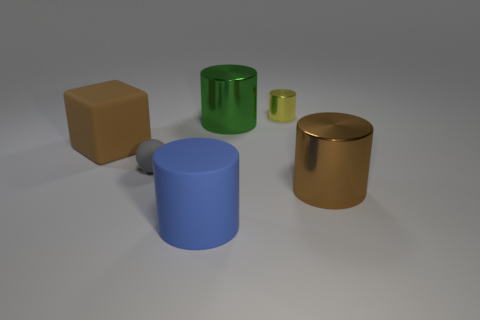Subtract all small yellow cylinders. How many cylinders are left? 3 Add 4 rubber cubes. How many objects exist? 10 Subtract all balls. How many objects are left? 5 Subtract all yellow cylinders. How many cylinders are left? 3 Subtract 1 cylinders. How many cylinders are left? 3 Add 3 tiny gray balls. How many tiny gray balls are left? 4 Add 2 big cylinders. How many big cylinders exist? 5 Subtract 1 brown cylinders. How many objects are left? 5 Subtract all gray blocks. Subtract all purple spheres. How many blocks are left? 1 Subtract all red metal blocks. Subtract all big shiny things. How many objects are left? 4 